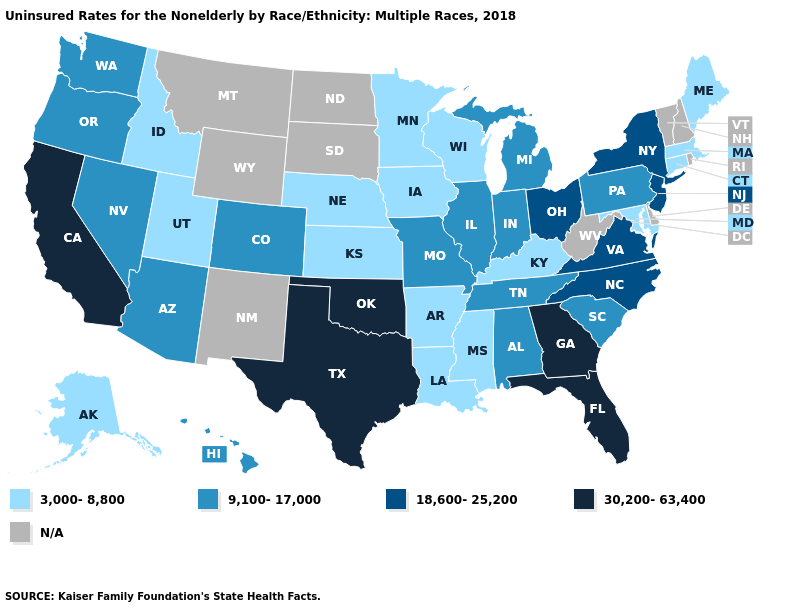Does Kansas have the highest value in the USA?
Answer briefly. No. Is the legend a continuous bar?
Quick response, please. No. Among the states that border Delaware , does Maryland have the highest value?
Give a very brief answer. No. What is the value of Arizona?
Write a very short answer. 9,100-17,000. Among the states that border Connecticut , which have the lowest value?
Concise answer only. Massachusetts. Name the states that have a value in the range 30,200-63,400?
Keep it brief. California, Florida, Georgia, Oklahoma, Texas. Among the states that border Georgia , does Alabama have the lowest value?
Quick response, please. Yes. What is the lowest value in states that border Vermont?
Concise answer only. 3,000-8,800. Does the first symbol in the legend represent the smallest category?
Concise answer only. Yes. Does Mississippi have the lowest value in the USA?
Short answer required. Yes. Among the states that border Arizona , which have the highest value?
Write a very short answer. California. What is the highest value in the USA?
Quick response, please. 30,200-63,400. Which states have the lowest value in the South?
Concise answer only. Arkansas, Kentucky, Louisiana, Maryland, Mississippi. 